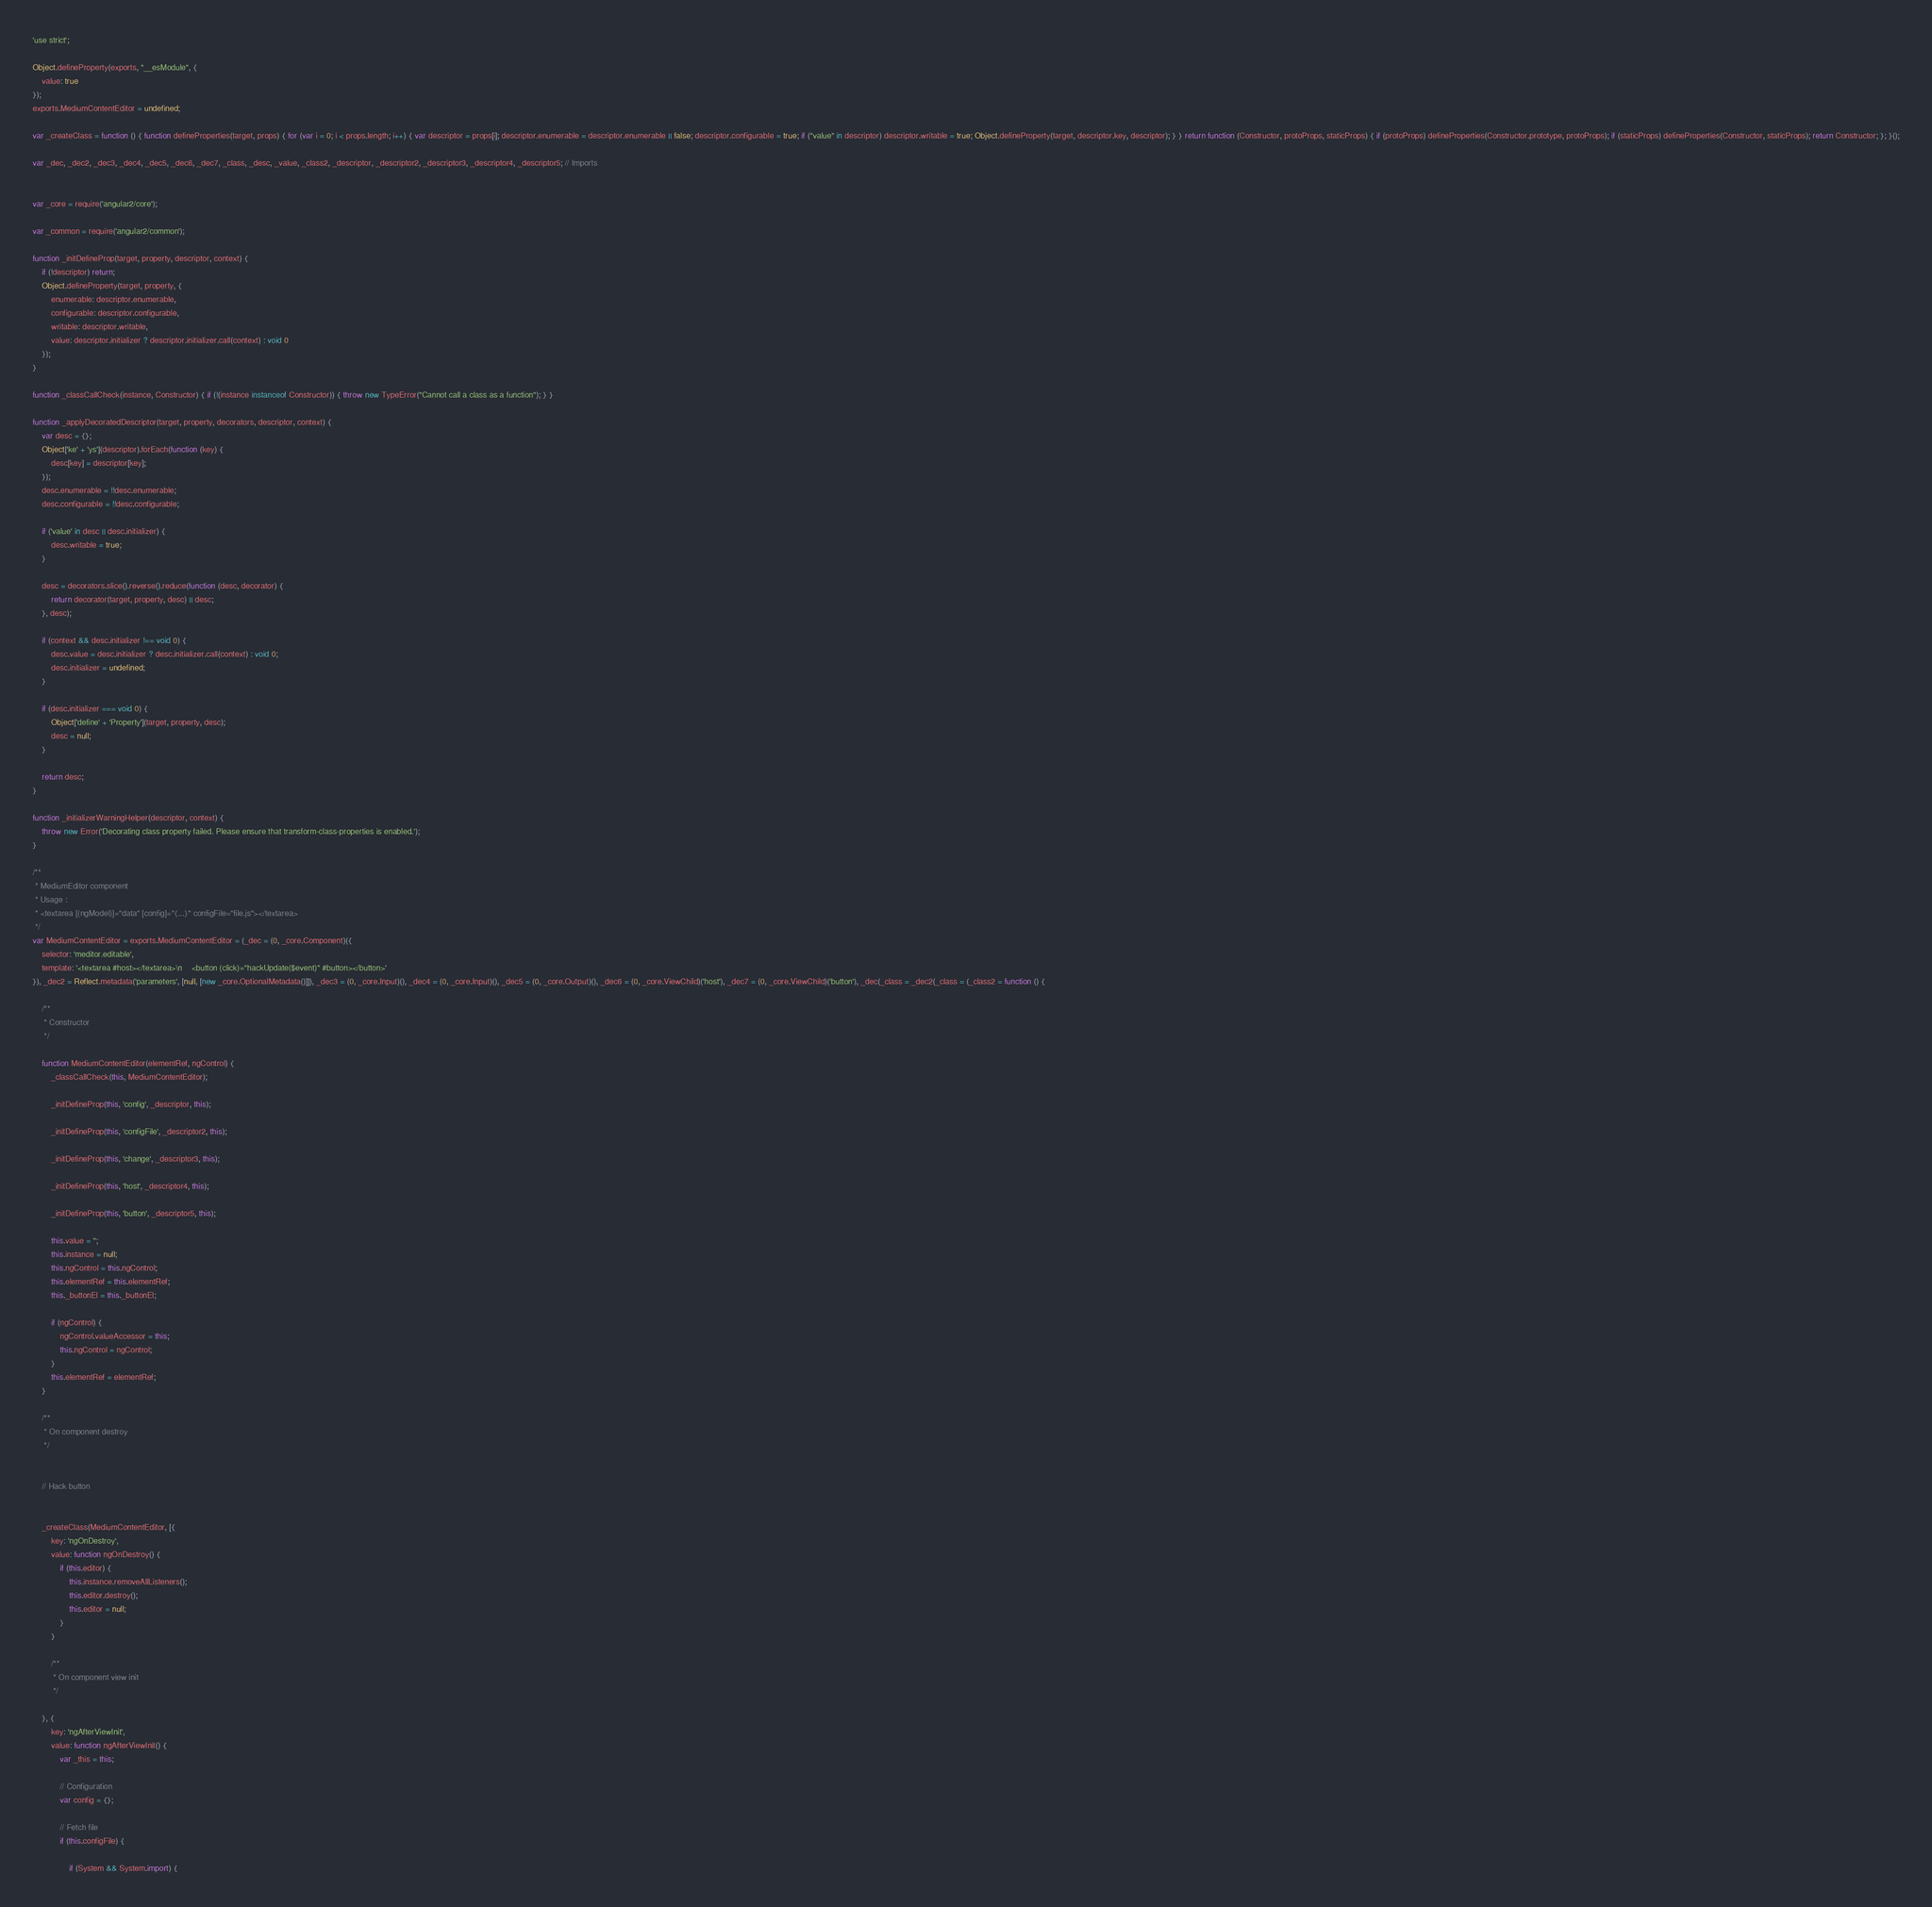Convert code to text. <code><loc_0><loc_0><loc_500><loc_500><_JavaScript_>'use strict';

Object.defineProperty(exports, "__esModule", {
    value: true
});
exports.MediumContentEditor = undefined;

var _createClass = function () { function defineProperties(target, props) { for (var i = 0; i < props.length; i++) { var descriptor = props[i]; descriptor.enumerable = descriptor.enumerable || false; descriptor.configurable = true; if ("value" in descriptor) descriptor.writable = true; Object.defineProperty(target, descriptor.key, descriptor); } } return function (Constructor, protoProps, staticProps) { if (protoProps) defineProperties(Constructor.prototype, protoProps); if (staticProps) defineProperties(Constructor, staticProps); return Constructor; }; }();

var _dec, _dec2, _dec3, _dec4, _dec5, _dec6, _dec7, _class, _desc, _value, _class2, _descriptor, _descriptor2, _descriptor3, _descriptor4, _descriptor5; // Imports


var _core = require('angular2/core');

var _common = require('angular2/common');

function _initDefineProp(target, property, descriptor, context) {
    if (!descriptor) return;
    Object.defineProperty(target, property, {
        enumerable: descriptor.enumerable,
        configurable: descriptor.configurable,
        writable: descriptor.writable,
        value: descriptor.initializer ? descriptor.initializer.call(context) : void 0
    });
}

function _classCallCheck(instance, Constructor) { if (!(instance instanceof Constructor)) { throw new TypeError("Cannot call a class as a function"); } }

function _applyDecoratedDescriptor(target, property, decorators, descriptor, context) {
    var desc = {};
    Object['ke' + 'ys'](descriptor).forEach(function (key) {
        desc[key] = descriptor[key];
    });
    desc.enumerable = !!desc.enumerable;
    desc.configurable = !!desc.configurable;

    if ('value' in desc || desc.initializer) {
        desc.writable = true;
    }

    desc = decorators.slice().reverse().reduce(function (desc, decorator) {
        return decorator(target, property, desc) || desc;
    }, desc);

    if (context && desc.initializer !== void 0) {
        desc.value = desc.initializer ? desc.initializer.call(context) : void 0;
        desc.initializer = undefined;
    }

    if (desc.initializer === void 0) {
        Object['define' + 'Property'](target, property, desc);
        desc = null;
    }

    return desc;
}

function _initializerWarningHelper(descriptor, context) {
    throw new Error('Decorating class property failed. Please ensure that transform-class-properties is enabled.');
}

/**
 * MediumEditor component
 * Usage :
 * <textarea [(ngModel)]="data" [config]="{...}" configFile="file.js"></textarea>
 */
var MediumContentEditor = exports.MediumContentEditor = (_dec = (0, _core.Component)({
    selector: 'meditor.editable',
    template: '<textarea #host></textarea>\n    <button (click)="hackUpdate($event)" #button></button>'
}), _dec2 = Reflect.metadata('parameters', [null, [new _core.OptionalMetadata()]]), _dec3 = (0, _core.Input)(), _dec4 = (0, _core.Input)(), _dec5 = (0, _core.Output)(), _dec6 = (0, _core.ViewChild)('host'), _dec7 = (0, _core.ViewChild)('button'), _dec(_class = _dec2(_class = (_class2 = function () {

    /**
     * Constructor
     */

    function MediumContentEditor(elementRef, ngControl) {
        _classCallCheck(this, MediumContentEditor);

        _initDefineProp(this, 'config', _descriptor, this);

        _initDefineProp(this, 'configFile', _descriptor2, this);

        _initDefineProp(this, 'change', _descriptor3, this);

        _initDefineProp(this, 'host', _descriptor4, this);

        _initDefineProp(this, 'button', _descriptor5, this);

        this.value = '';
        this.instance = null;
        this.ngControl = this.ngControl;
        this.elementRef = this.elementRef;
        this._buttonEl = this._buttonEl;

        if (ngControl) {
            ngControl.valueAccessor = this;
            this.ngControl = ngControl;
        }
        this.elementRef = elementRef;
    }

    /**
     * On component destroy
     */


    // Hack button


    _createClass(MediumContentEditor, [{
        key: 'ngOnDestroy',
        value: function ngOnDestroy() {
            if (this.editor) {
                this.instance.removeAllListeners();
                this.editor.destroy();
                this.editor = null;
            }
        }

        /**
         * On component view init
         */

    }, {
        key: 'ngAfterViewInit',
        value: function ngAfterViewInit() {
            var _this = this;

            // Configuration
            var config = {};

            // Fetch file
            if (this.configFile) {

                if (System && System.import) {</code> 